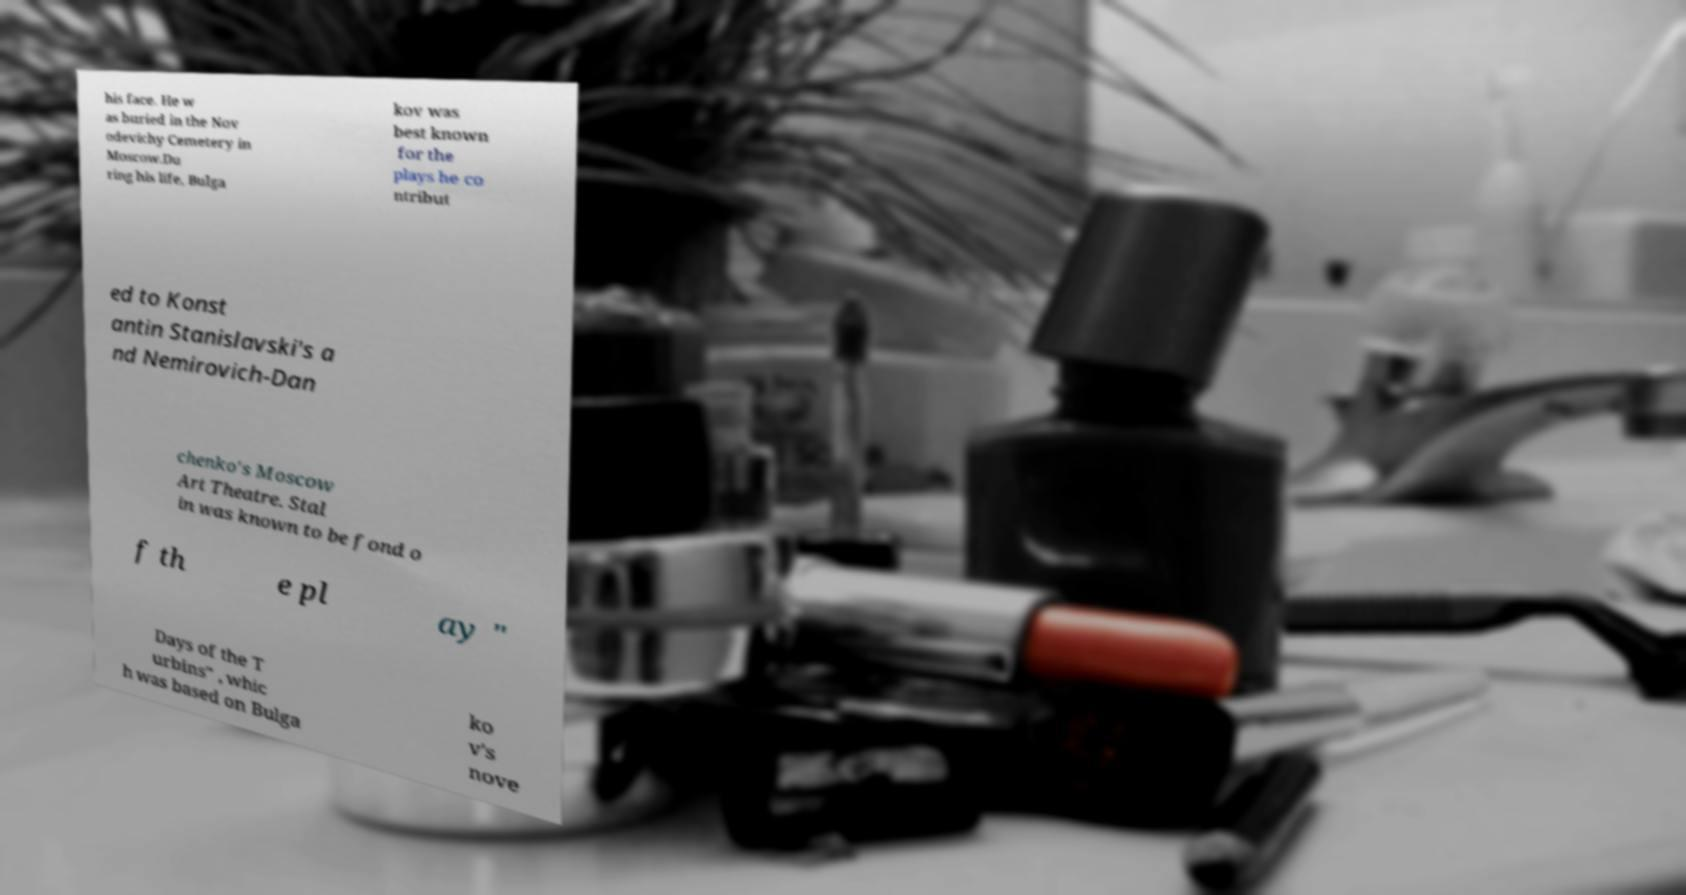Could you assist in decoding the text presented in this image and type it out clearly? his face. He w as buried in the Nov odevichy Cemetery in Moscow.Du ring his life, Bulga kov was best known for the plays he co ntribut ed to Konst antin Stanislavski's a nd Nemirovich-Dan chenko's Moscow Art Theatre. Stal in was known to be fond o f th e pl ay " Days of the T urbins" , whic h was based on Bulga ko v's nove 